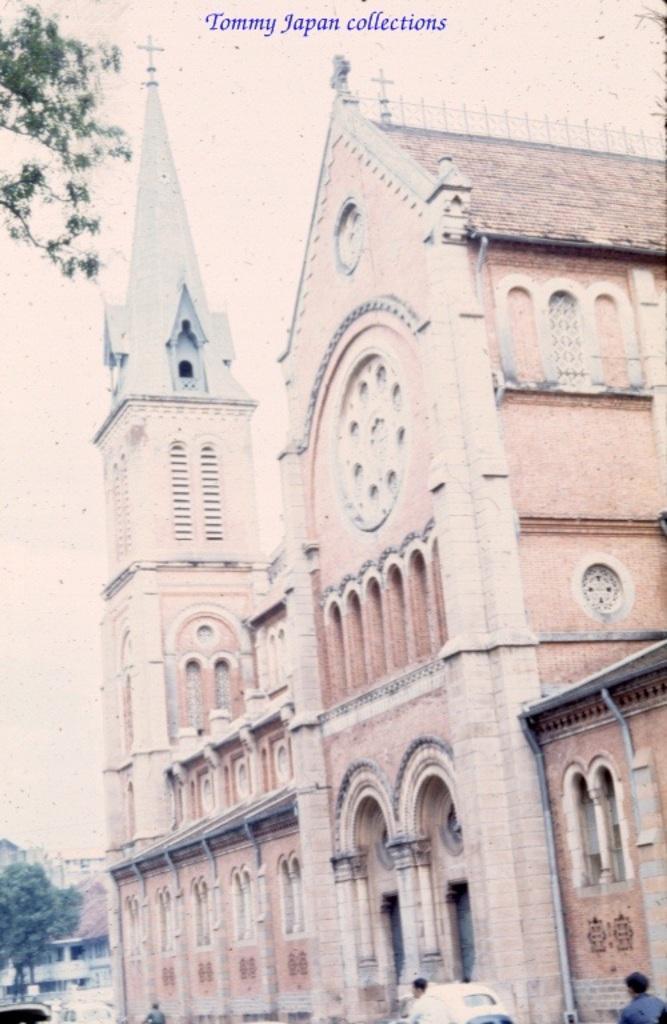Describe this image in one or two sentences. This is an edited picture. In this image there are buildings and trees. At the bottom there are vehicles and there are people. There is a pipe and there is a clock on the wall. At the top there is sky and there is a text. 